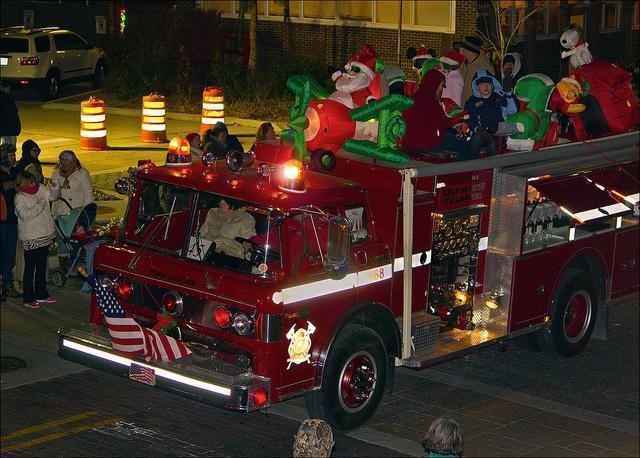What sort of Holiday parade is being feted here?
Make your selection from the four choices given to correctly answer the question.
Options: Christmas, st patricks, flag day, veterans day. Christmas. 